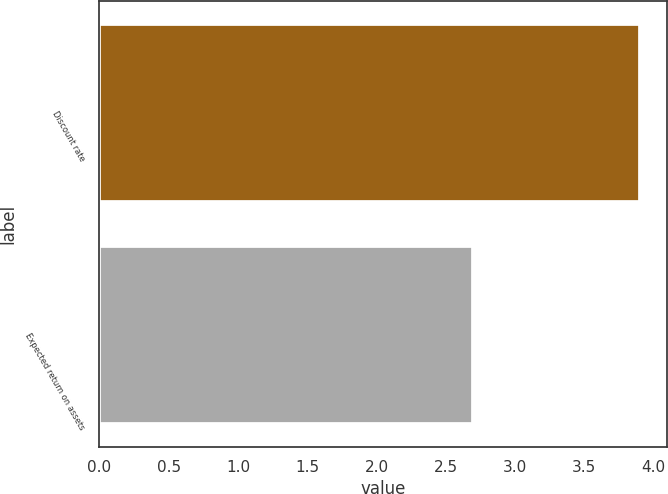Convert chart to OTSL. <chart><loc_0><loc_0><loc_500><loc_500><bar_chart><fcel>Discount rate<fcel>Expected return on assets<nl><fcel>3.9<fcel>2.7<nl></chart> 